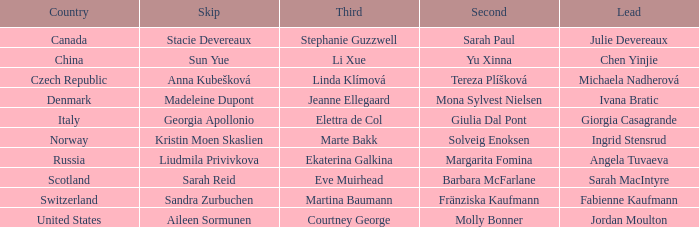What skip has denmark as the country? Madeleine Dupont. 